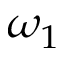Convert formula to latex. <formula><loc_0><loc_0><loc_500><loc_500>\omega _ { 1 }</formula> 